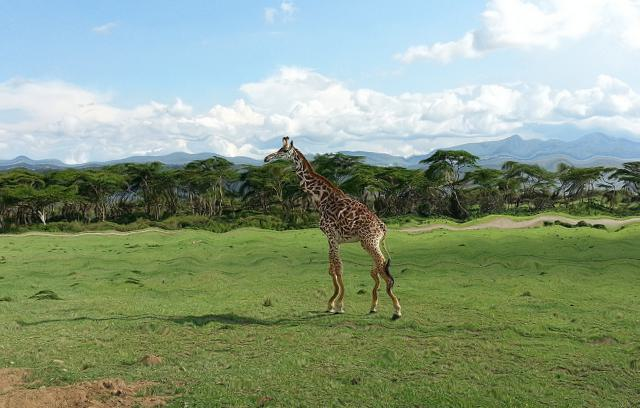Is there any indication of the giraffe's age or condition in this image? The giraffe appears to be in good health, with a robust and well-defined body indicating it is well-nourished. Its coat is smooth and patterns are distinct, often a sign of a younger animal. Signs of wear or patchiness, often seen in older giraffes, are not present. 